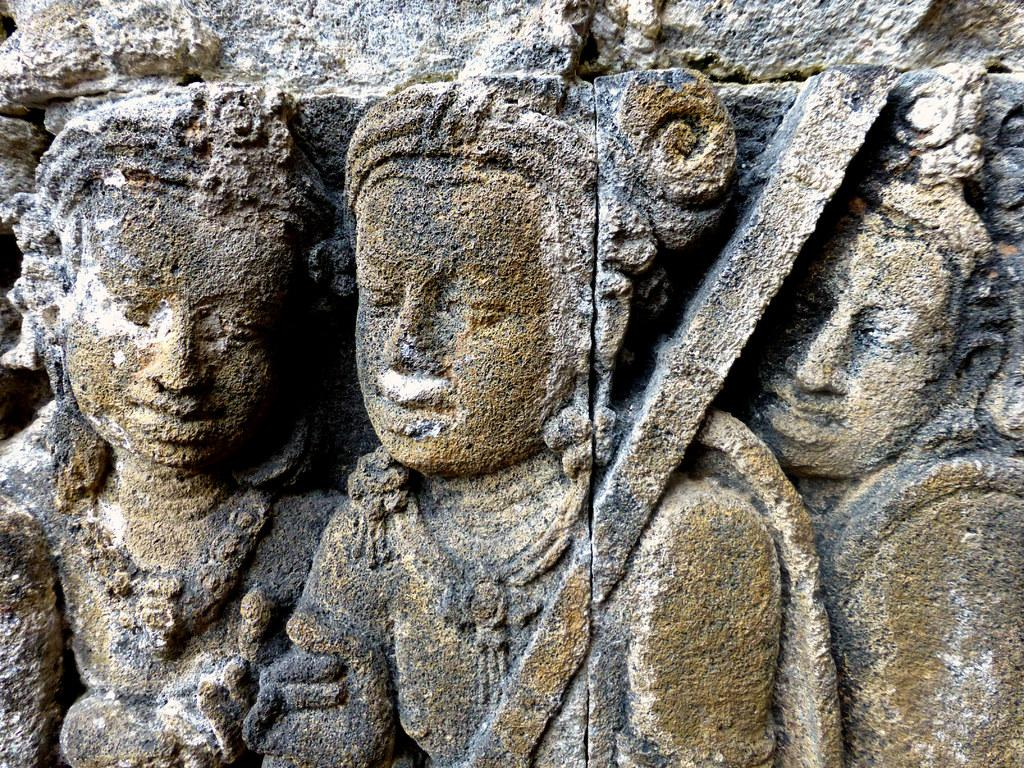What type of objects are depicted in the image? There are stone carved statues in the image. Can you describe the material used to create the statues? The statues are made of stone. What might be the purpose of these statues? The statues could be decorative or serve a cultural or historical significance. Where is the sink located in the image? There is no sink present in the image; it only features stone carved statues. 